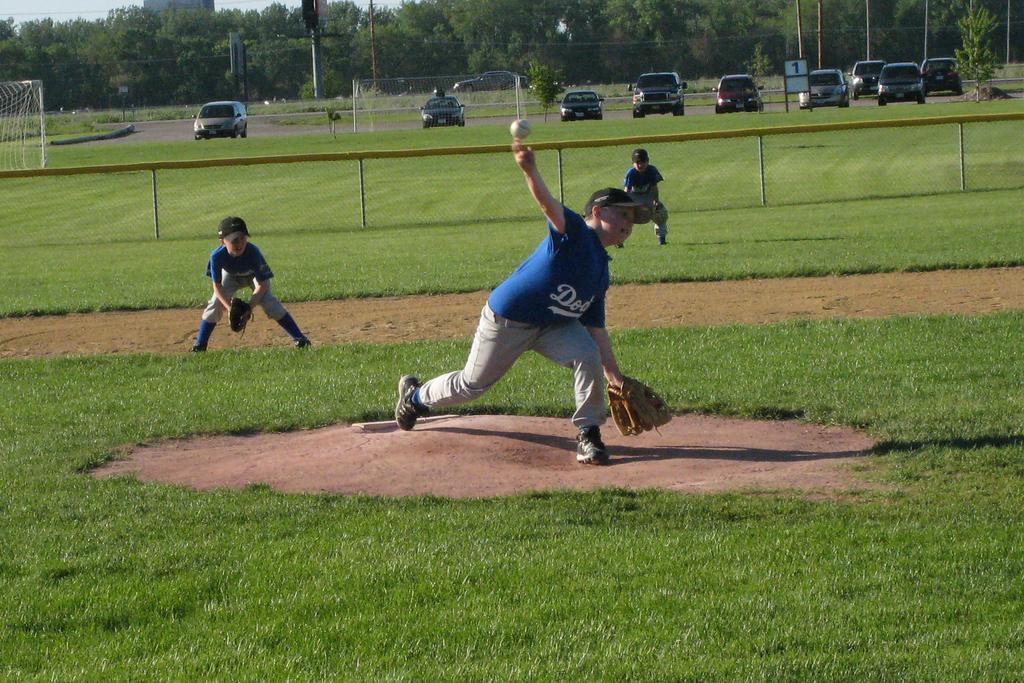Can you describe this image briefly? At the bottom of the image we can see grass. In the middle of the image three persons are standing and he is throwing a ball. Behind them we can see fencing. Behind the fencing we can see some vehicles, poles, trees and buildings. 